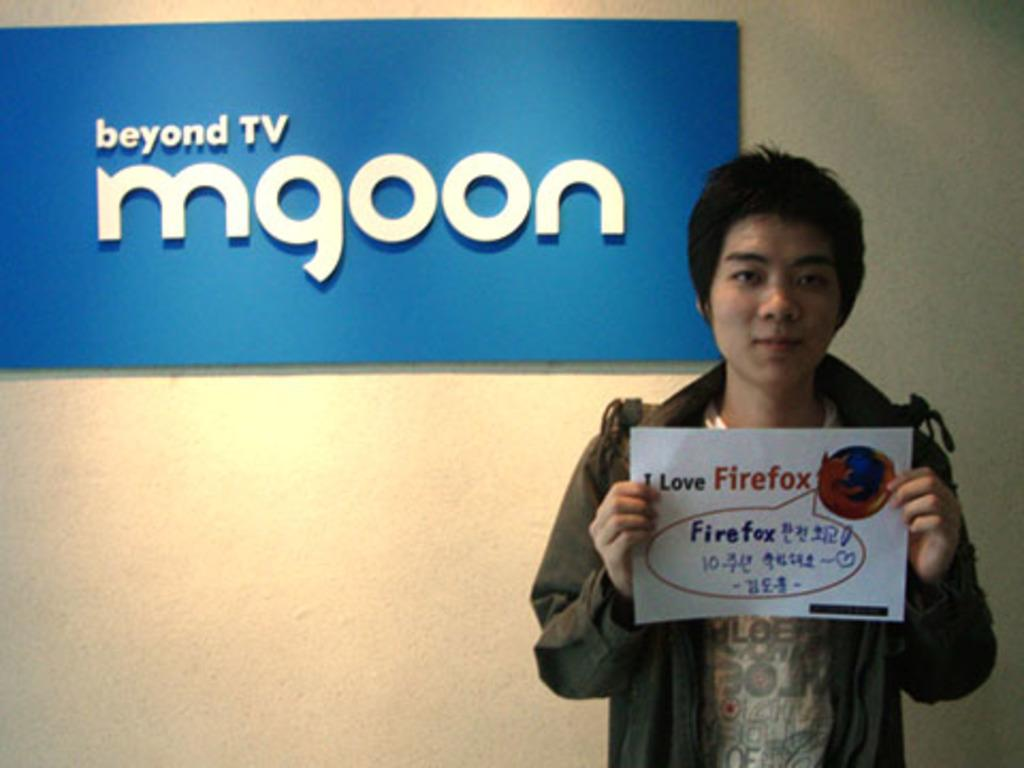What is the person in the image doing? The person is standing in the image and holding a poster. What can be seen behind the person in the image? There is a wall and a board visible in the background of the image. What type of magic is the person performing with the poster in the image? There is no indication of magic or any magical activity in the image; the person is simply holding a poster. 